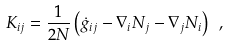<formula> <loc_0><loc_0><loc_500><loc_500>K _ { i j } = \frac { 1 } { 2 N } \left ( \dot { g } _ { i j } - \nabla _ { i } N _ { j } - \nabla _ { j } N _ { i } \right ) \ ,</formula> 